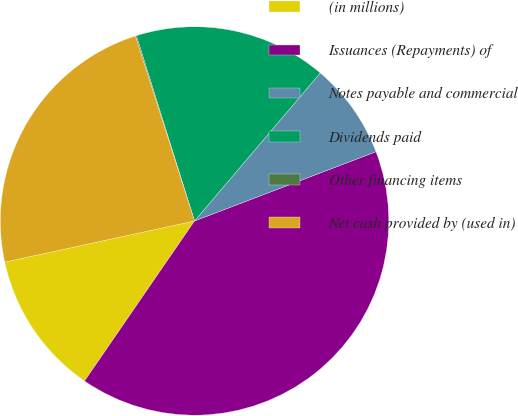Convert chart to OTSL. <chart><loc_0><loc_0><loc_500><loc_500><pie_chart><fcel>(in millions)<fcel>Issuances (Repayments) of<fcel>Notes payable and commercial<fcel>Dividends paid<fcel>Other financing items<fcel>Net cash provided by (used in)<nl><fcel>12.02%<fcel>40.39%<fcel>7.99%<fcel>16.05%<fcel>0.09%<fcel>23.47%<nl></chart> 